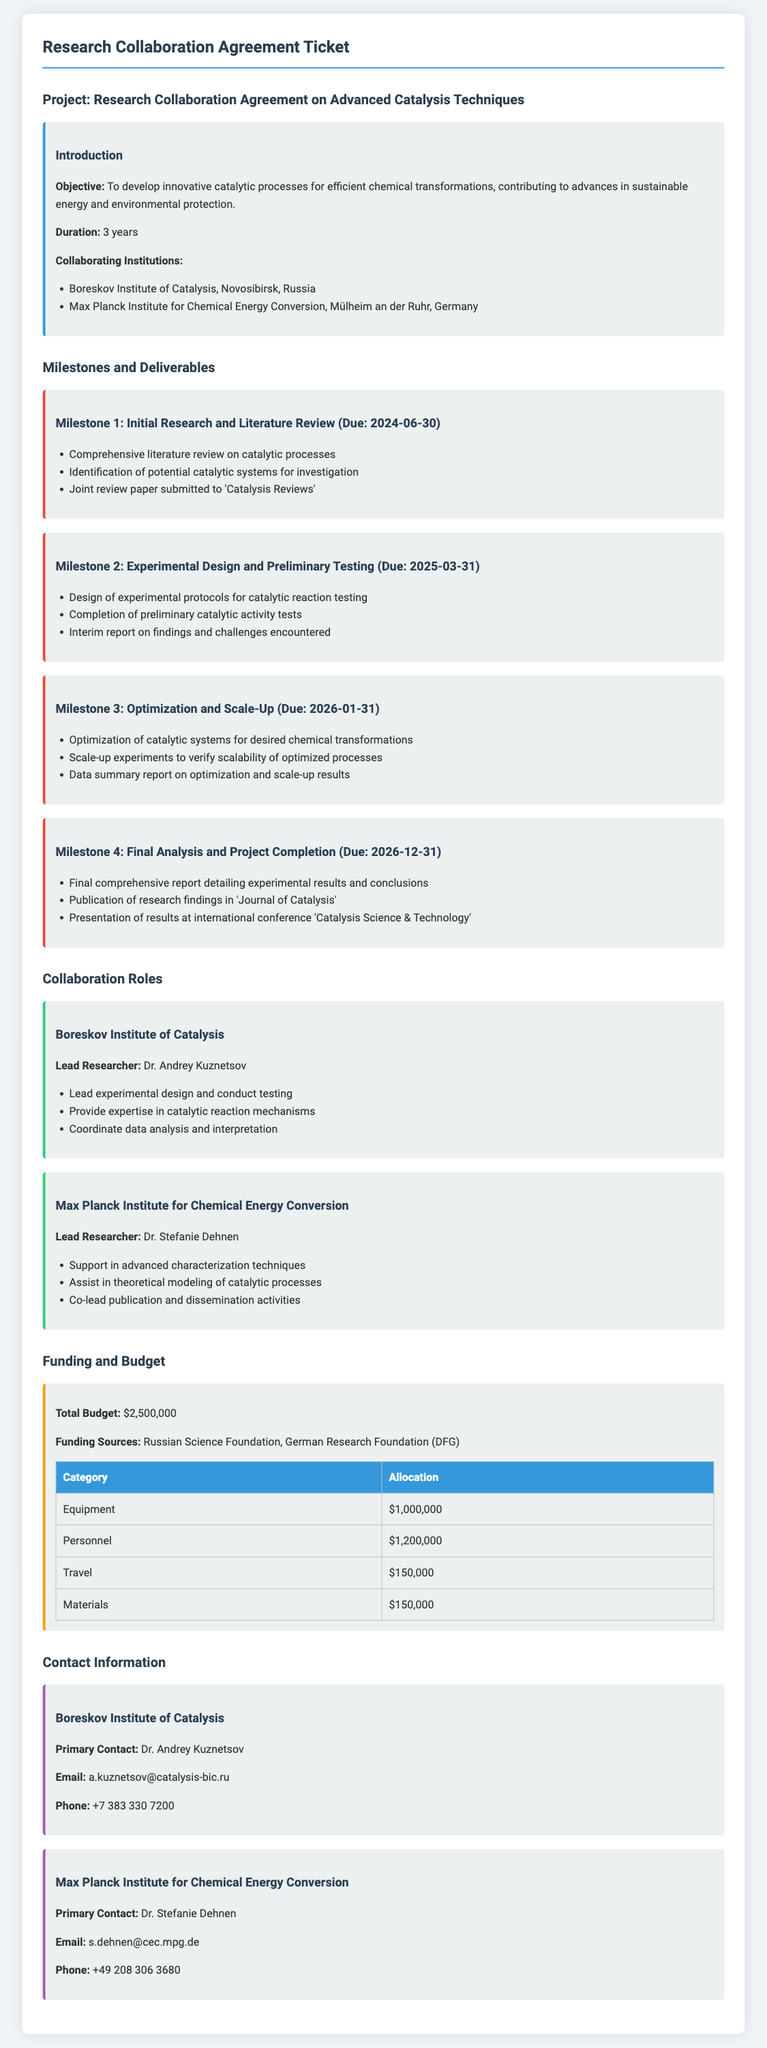What is the objective of the project? The objective is to develop innovative catalytic processes for efficient chemical transformations, contributing to advances in sustainable energy and environmental protection.
Answer: To develop innovative catalytic processes for efficient chemical transformations What is the duration of the collaboration? The duration is specified as the length of the project, which is 3 years.
Answer: 3 years Who is the lead researcher from the Boreskov Institute of Catalysis? The document identifies Dr. Andrey Kuznetsov as the lead researcher from the Boreskov Institute of Catalysis.
Answer: Dr. Andrey Kuznetsov When is Milestone 3 due? Milestone 3, which is about Optimization and Scale-Up, is due on January 31, 2026.
Answer: 2026-01-31 What is the total budget for the project? The total budget is explicitly mentioned in the document as $2,500,000.
Answer: $2,500,000 Which two institutions are collaborating on this project? The collaborating institutions are Boreskov Institute of Catalysis and Max Planck Institute for Chemical Energy Conversion, as stated in the introduction.
Answer: Boreskov Institute of Catalysis, Max Planck Institute for Chemical Energy Conversion What is the primary contact email for Dr. Stefanie Dehnen? The document provides the email for Dr. Stefanie Dehnen, which is included in the contact information section.
Answer: s.dehnen@cec.mpg.de What is one primary responsibility of the Max Planck Institute in this collaboration? The document mentions that one of the responsibilities includes supporting advanced characterization techniques.
Answer: Support in advanced characterization techniques What is the due date for the final analysis and project completion? The due date for the final analysis and project completion is specified as December 31, 2026.
Answer: 2026-12-31 